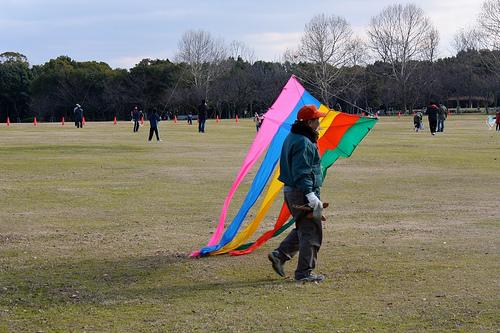What color is the object the man is carrying?
Concise answer only. Rainbow. What are the people doing in the photograph?
Write a very short answer. Flying kites. What colorful object is the man carrying?
Give a very brief answer. Kite. 